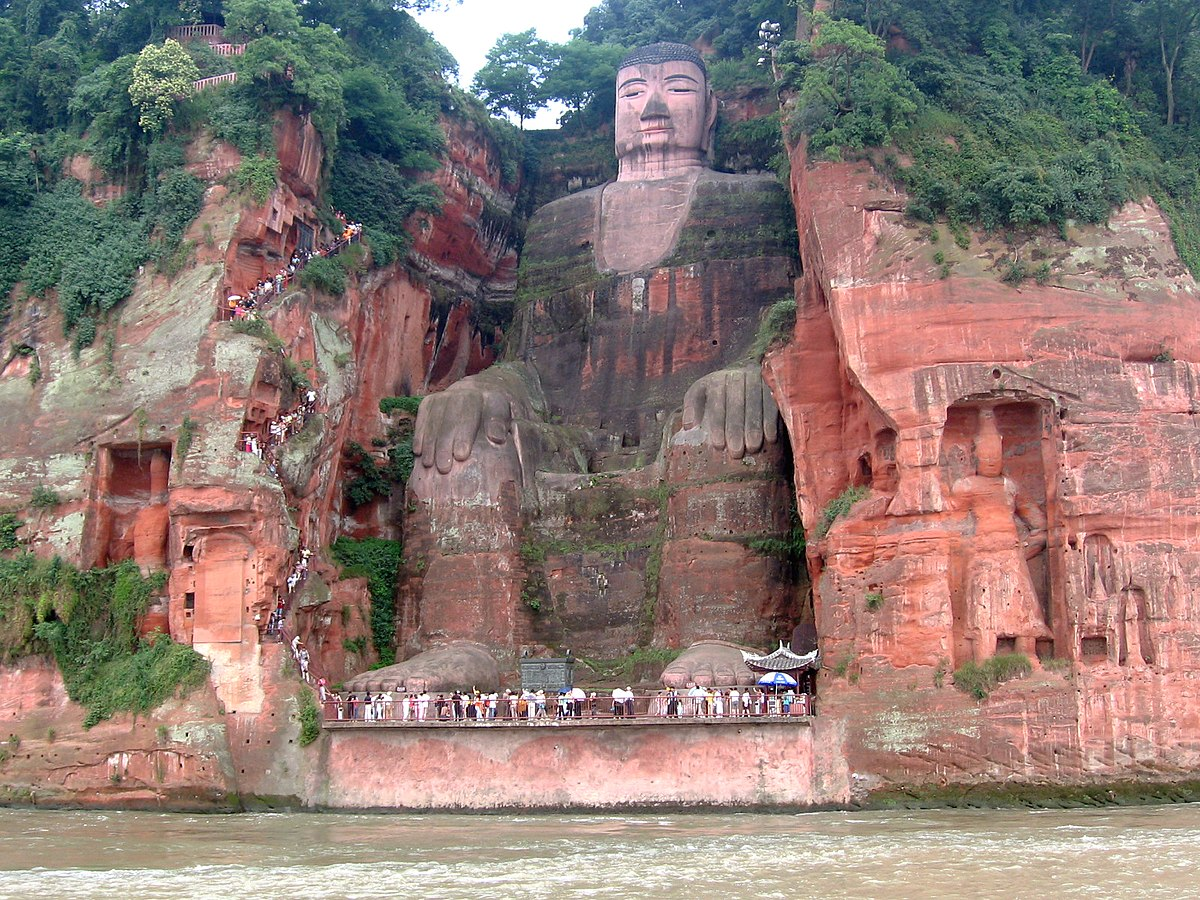How did the construction of the Leshan Giant Buddha impact its surrounding environment? The construction of the Leshan Giant Buddha had a significant environmental impact. By altering the landscape, it helped calm the once violent river confluence below, making navigation safer for boats. The region around the Buddha was transformed into a more stable and serene environment. Additionally, the preservation efforts have led to the conservation of surrounding woodlands and river ecosystems, crucial for maintaining the region’s biodiversity. These efforts highlight the intricate balance between cultural heritage and environmental conservation. 